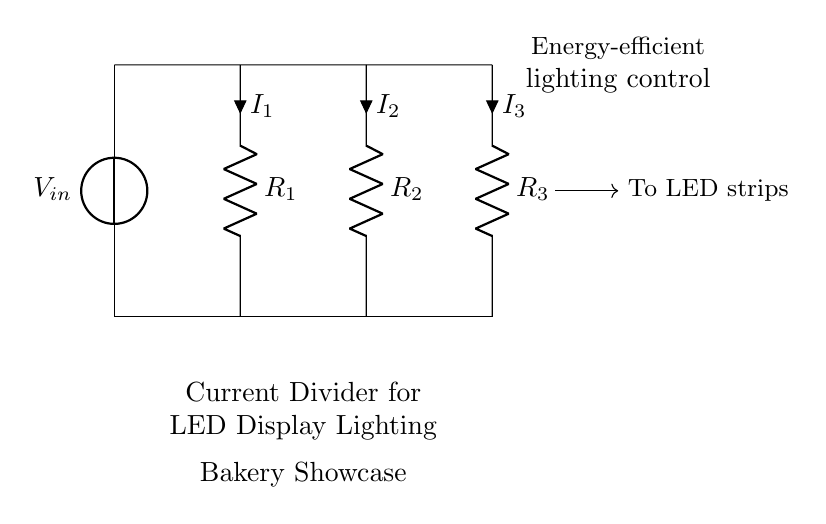What is the input voltage of the circuit? The input voltage, denoted as V_in, is the potential difference provided by the voltage source in the circuit. It is located at the top left of the diagram, where the voltage source connects.
Answer: V_in What are the resistances in the circuit? The circuit contains three resistors indicated as R_1, R_2, and R_3. Each resistor is labeled and positioned vertically in the circuit diagram, depicting their distinct contributions to the current division.
Answer: R_1, R_2, R_3 How many branches does the current divide into? The circuit shows three parallel branches. Each branch corresponds to one of the resistors (R_1, R_2, R_3), where the current splits as it flows through these resistors.
Answer: Three What is the relationship between current division and resistance? According to the current divider rule, the current flowing through each resistor is inversely proportional to its resistance. Thus, a lower resistance will carry a larger share of the total current.
Answer: Inversely proportional What does the "To LED strips" arrow indicate? The arrow labeled "To LED strips" signifies that the current coming from the branches is directed towards LED lighting. This connection is crucial for the application of the circuit in energy-efficient lighting for the bakery showcase.
Answer: Power supply for LEDs What is the role of this circuit in the bakery context? This current divider circuit is specifically designed to control the distribution of current for energy-efficient LED lighting in showcases. It highlights the intended application to create visually appealing displays while saving energy.
Answer: LED display lighting How does this setup enhance energy efficiency? By using a current divider circuit, the setup allows for precise control of current distribution among the LEDs, which leads to improved energy efficiency by ensuring optimal brightness without excess power consumption.
Answer: Energy-efficient lighting control 